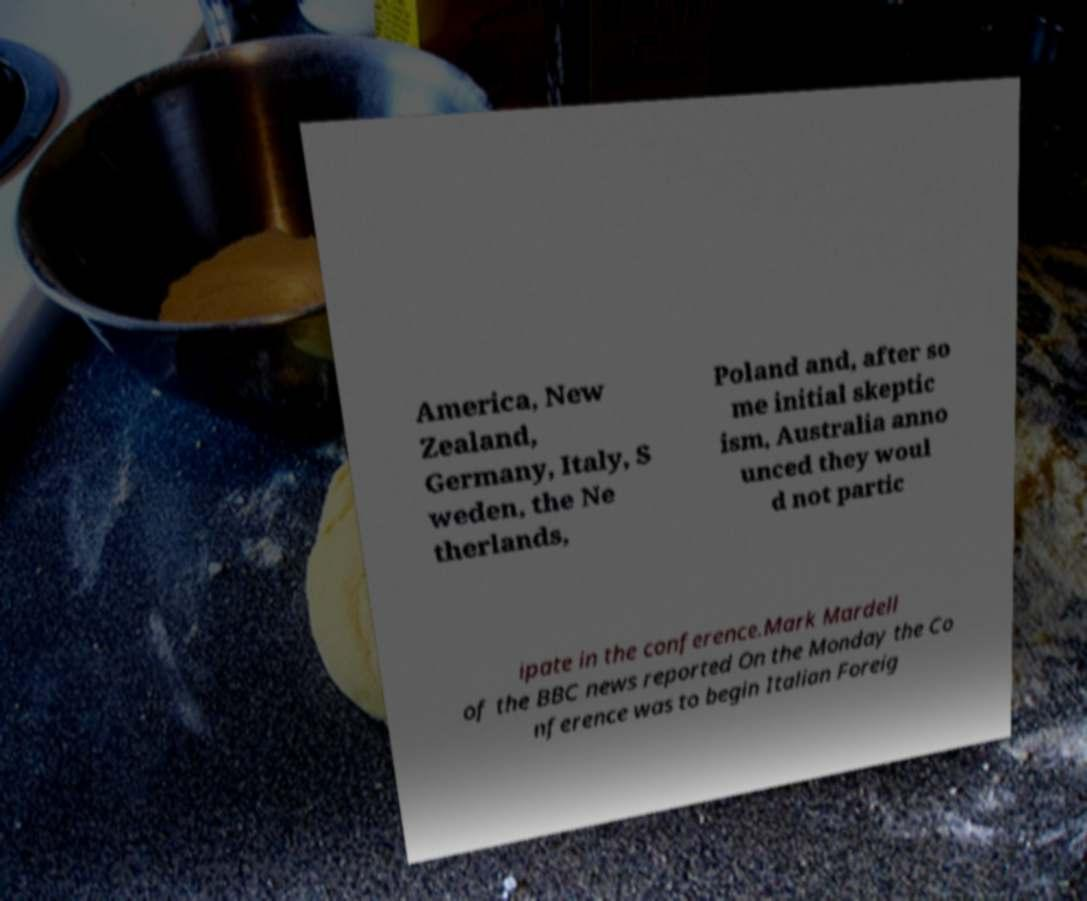Please read and relay the text visible in this image. What does it say? America, New Zealand, Germany, Italy, S weden, the Ne therlands, Poland and, after so me initial skeptic ism, Australia anno unced they woul d not partic ipate in the conference.Mark Mardell of the BBC news reported On the Monday the Co nference was to begin Italian Foreig 